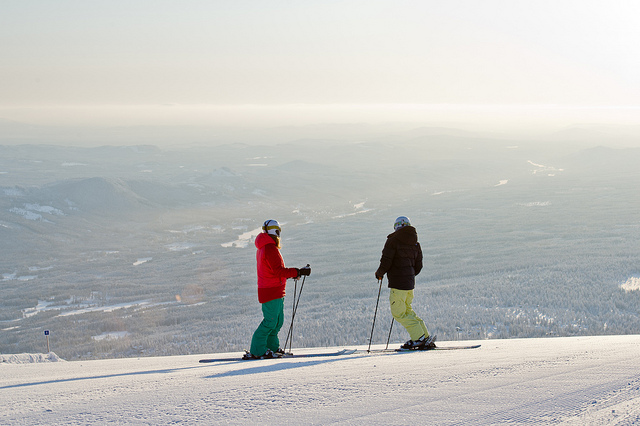<image>Is this one male and one female? It is ambiguous to tell if one is male and one is female. Is this one male and one female? I am not sure if this one is male and one is female. 